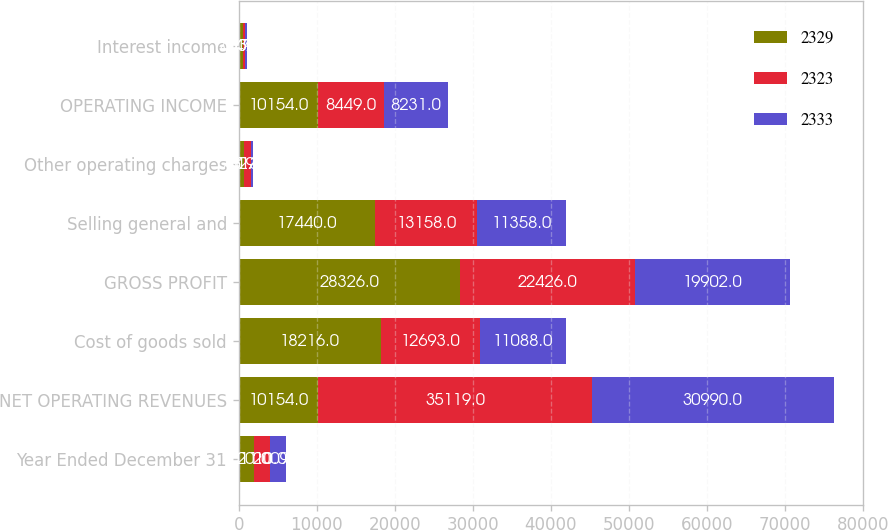<chart> <loc_0><loc_0><loc_500><loc_500><stacked_bar_chart><ecel><fcel>Year Ended December 31<fcel>NET OPERATING REVENUES<fcel>Cost of goods sold<fcel>GROSS PROFIT<fcel>Selling general and<fcel>Other operating charges<fcel>OPERATING INCOME<fcel>Interest income<nl><fcel>2329<fcel>2011<fcel>10154<fcel>18216<fcel>28326<fcel>17440<fcel>732<fcel>10154<fcel>483<nl><fcel>2323<fcel>2010<fcel>35119<fcel>12693<fcel>22426<fcel>13158<fcel>819<fcel>8449<fcel>317<nl><fcel>2333<fcel>2009<fcel>30990<fcel>11088<fcel>19902<fcel>11358<fcel>313<fcel>8231<fcel>249<nl></chart> 